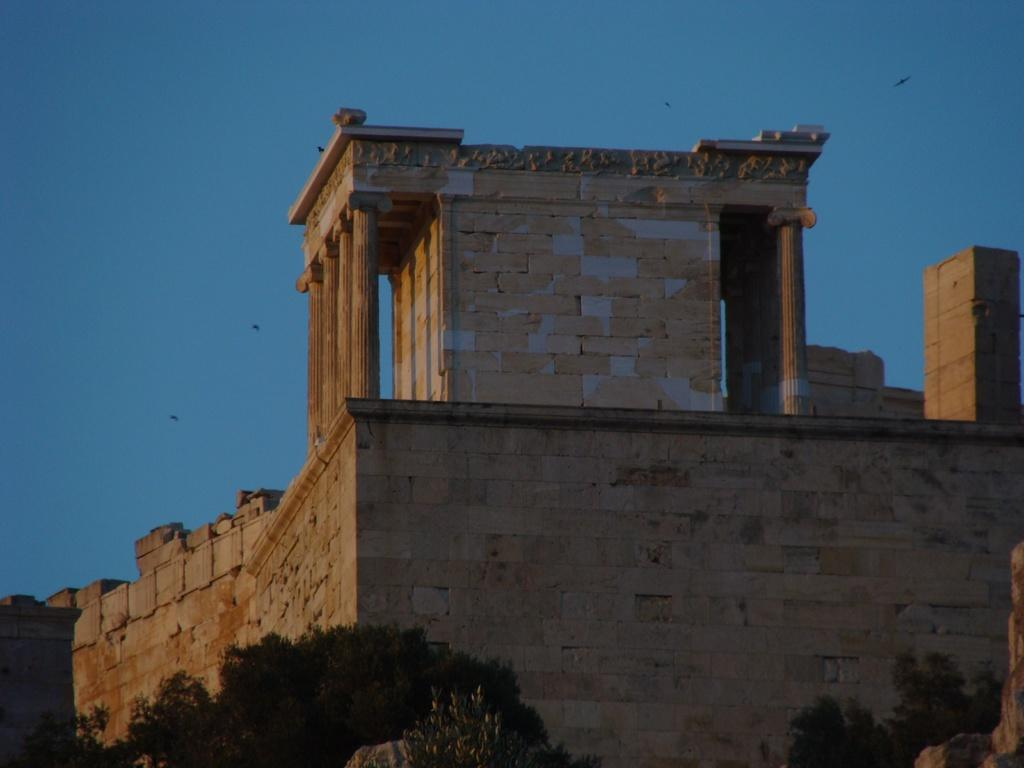What is the main structure in the image? There is a monument in the image. What else can be seen in the image besides the monument? There is a wall, trees, and birds visible in the image. What is the natural element present in the image? Trees are the natural element present in the image. What is visible in the background of the image? The sky is visible in the image. How many rabbits can be seen playing with the dog in the image? There are no rabbits or dogs present in the image. What type of judge is depicted in the image? There is no judge depicted in the image; it features a monument, a wall, trees, birds, and the sky. 